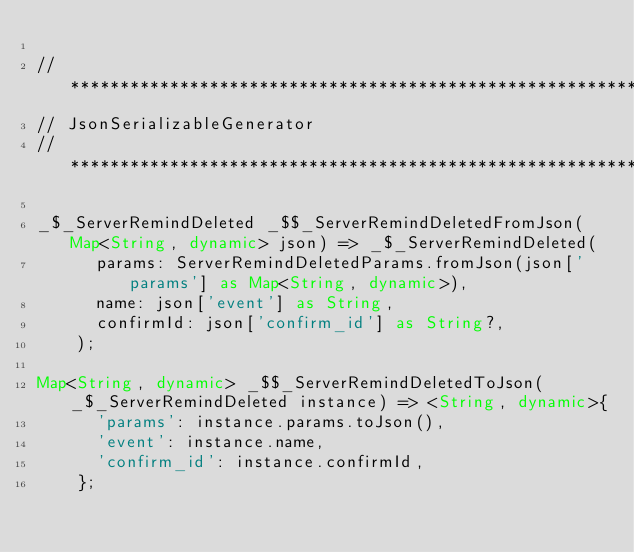<code> <loc_0><loc_0><loc_500><loc_500><_Dart_>
// **************************************************************************
// JsonSerializableGenerator
// **************************************************************************

_$_ServerRemindDeleted _$$_ServerRemindDeletedFromJson(Map<String, dynamic> json) => _$_ServerRemindDeleted(
      params: ServerRemindDeletedParams.fromJson(json['params'] as Map<String, dynamic>),
      name: json['event'] as String,
      confirmId: json['confirm_id'] as String?,
    );

Map<String, dynamic> _$$_ServerRemindDeletedToJson(_$_ServerRemindDeleted instance) => <String, dynamic>{
      'params': instance.params.toJson(),
      'event': instance.name,
      'confirm_id': instance.confirmId,
    };
</code> 